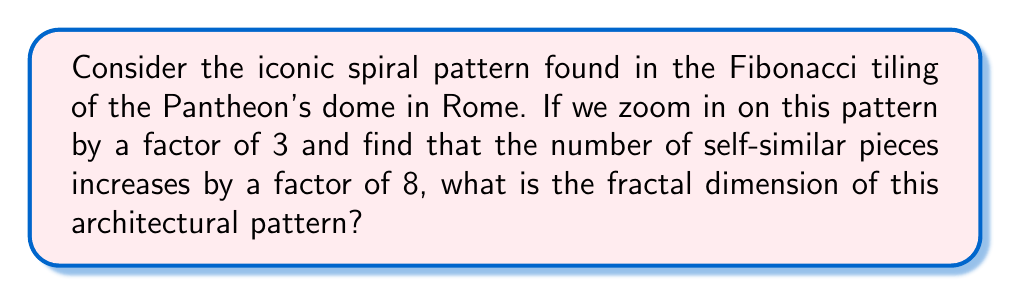Give your solution to this math problem. To determine the fractal dimension of the Pantheon's dome pattern, we'll use the fundamental principle of fractal geometry: self-similarity across different scales. The fractal dimension, denoted as $D$, is a measure of how the detail of a pattern changes with the scale at which it is measured.

For self-similar fractals, we can use the following formula:

$$ D = \frac{\log N}{\log S} $$

Where:
- $N$ is the number of self-similar pieces
- $S$ is the scaling factor

In this case:
- The scaling factor $S = 3$ (we zoom in by a factor of 3)
- The number of self-similar pieces $N = 8$ (the number of pieces increases by a factor of 8)

Let's substitute these values into our equation:

$$ D = \frac{\log 8}{\log 3} $$

Now, let's calculate this:

$$ D = \frac{\log 8}{\log 3} \approx \frac{2.0794}{1.0986} \approx 1.8928 $$

This fractal dimension lies between 1 and 2, which is typical for many architectural patterns. It indicates that the pattern is more complex than a simple line (dimension 1) but doesn't quite fill a plane (dimension 2).
Answer: The fractal dimension of the architectural pattern is approximately 1.8928. 